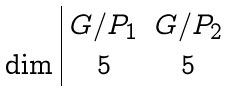Convert formula to latex. <formula><loc_0><loc_0><loc_500><loc_500>\begin{array} { l | c c } & G / P _ { 1 } & G / P _ { 2 } \\ \dim & 5 & 5 \end{array}</formula> 